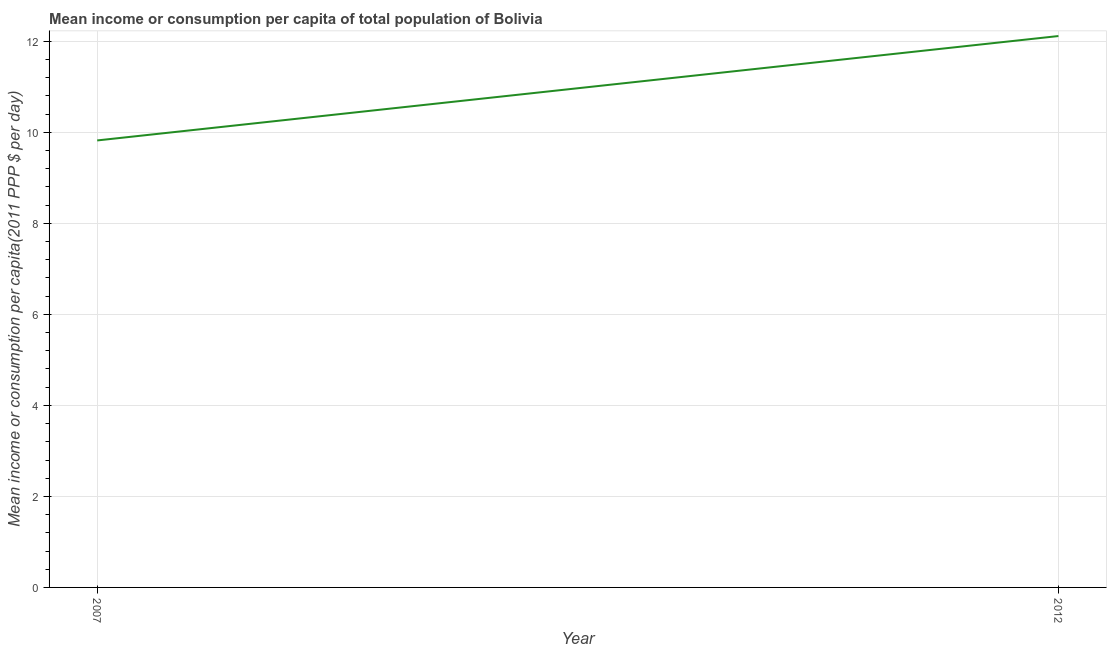What is the mean income or consumption in 2007?
Your response must be concise. 9.82. Across all years, what is the maximum mean income or consumption?
Make the answer very short. 12.12. Across all years, what is the minimum mean income or consumption?
Offer a very short reply. 9.82. In which year was the mean income or consumption minimum?
Ensure brevity in your answer.  2007. What is the sum of the mean income or consumption?
Make the answer very short. 21.94. What is the difference between the mean income or consumption in 2007 and 2012?
Give a very brief answer. -2.29. What is the average mean income or consumption per year?
Your response must be concise. 10.97. What is the median mean income or consumption?
Your answer should be compact. 10.97. In how many years, is the mean income or consumption greater than 10.4 $?
Keep it short and to the point. 1. What is the ratio of the mean income or consumption in 2007 to that in 2012?
Your response must be concise. 0.81. Does the mean income or consumption monotonically increase over the years?
Make the answer very short. Yes. How many years are there in the graph?
Provide a succinct answer. 2. What is the difference between two consecutive major ticks on the Y-axis?
Make the answer very short. 2. Are the values on the major ticks of Y-axis written in scientific E-notation?
Your answer should be compact. No. What is the title of the graph?
Keep it short and to the point. Mean income or consumption per capita of total population of Bolivia. What is the label or title of the X-axis?
Offer a terse response. Year. What is the label or title of the Y-axis?
Your answer should be compact. Mean income or consumption per capita(2011 PPP $ per day). What is the Mean income or consumption per capita(2011 PPP $ per day) in 2007?
Offer a terse response. 9.82. What is the Mean income or consumption per capita(2011 PPP $ per day) of 2012?
Ensure brevity in your answer.  12.12. What is the difference between the Mean income or consumption per capita(2011 PPP $ per day) in 2007 and 2012?
Offer a very short reply. -2.29. What is the ratio of the Mean income or consumption per capita(2011 PPP $ per day) in 2007 to that in 2012?
Your answer should be compact. 0.81. 